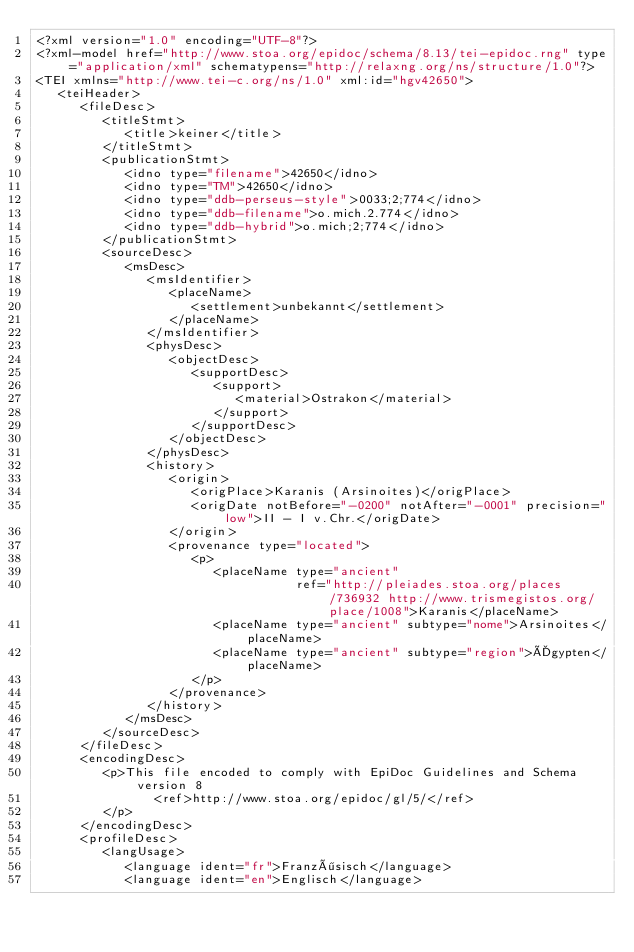<code> <loc_0><loc_0><loc_500><loc_500><_XML_><?xml version="1.0" encoding="UTF-8"?>
<?xml-model href="http://www.stoa.org/epidoc/schema/8.13/tei-epidoc.rng" type="application/xml" schematypens="http://relaxng.org/ns/structure/1.0"?>
<TEI xmlns="http://www.tei-c.org/ns/1.0" xml:id="hgv42650">
   <teiHeader>
      <fileDesc>
         <titleStmt>
            <title>keiner</title>
         </titleStmt>
         <publicationStmt>
            <idno type="filename">42650</idno>
            <idno type="TM">42650</idno>
            <idno type="ddb-perseus-style">0033;2;774</idno>
            <idno type="ddb-filename">o.mich.2.774</idno>
            <idno type="ddb-hybrid">o.mich;2;774</idno>
         </publicationStmt>
         <sourceDesc>
            <msDesc>
               <msIdentifier>
                  <placeName>
                     <settlement>unbekannt</settlement>
                  </placeName>
               </msIdentifier>
               <physDesc>
                  <objectDesc>
                     <supportDesc>
                        <support>
                           <material>Ostrakon</material>
                        </support>
                     </supportDesc>
                  </objectDesc>
               </physDesc>
               <history>
                  <origin>
                     <origPlace>Karanis (Arsinoites)</origPlace>
                     <origDate notBefore="-0200" notAfter="-0001" precision="low">II - I v.Chr.</origDate>
                  </origin>
                  <provenance type="located">
                     <p>
                        <placeName type="ancient"
                                   ref="http://pleiades.stoa.org/places/736932 http://www.trismegistos.org/place/1008">Karanis</placeName>
                        <placeName type="ancient" subtype="nome">Arsinoites</placeName>
                        <placeName type="ancient" subtype="region">Ägypten</placeName>
                     </p>
                  </provenance>
               </history>
            </msDesc>
         </sourceDesc>
      </fileDesc>
      <encodingDesc>
         <p>This file encoded to comply with EpiDoc Guidelines and Schema version 8
                <ref>http://www.stoa.org/epidoc/gl/5/</ref>
         </p>
      </encodingDesc>
      <profileDesc>
         <langUsage>
            <language ident="fr">Französisch</language>
            <language ident="en">Englisch</language></code> 